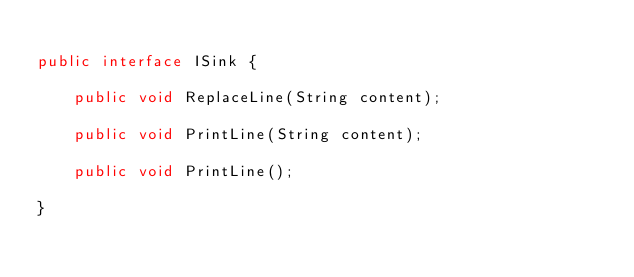Convert code to text. <code><loc_0><loc_0><loc_500><loc_500><_Java_>
public interface ISink {
	
	public void ReplaceLine(String content);
	
	public void PrintLine(String content);
	
	public void PrintLine();
	
}
</code> 